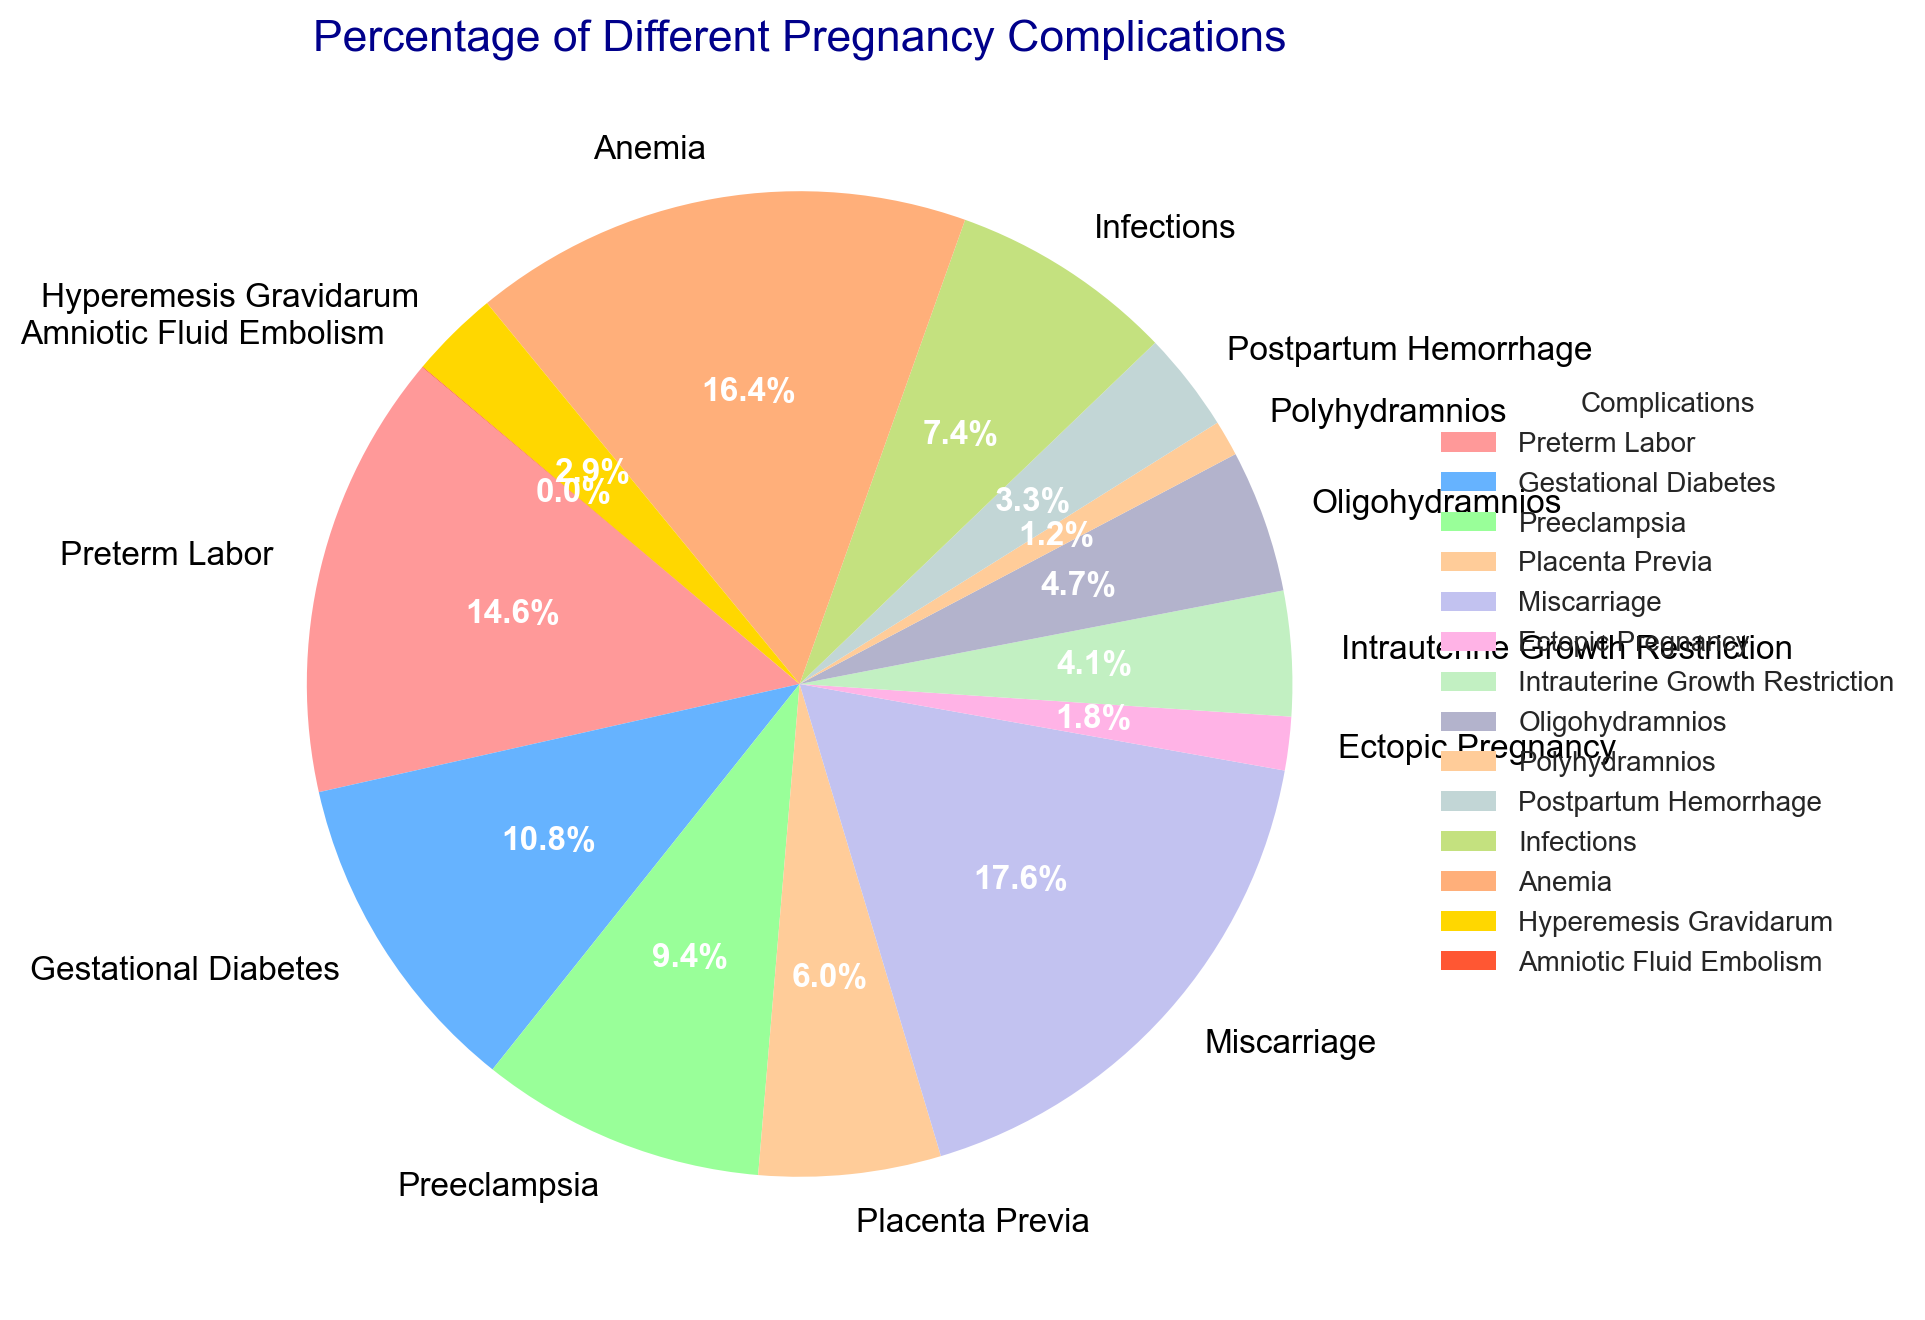Which complication has the highest percentage? By observing the sizes of the slices in the pie chart, you can determine that the largest slice represents the complication with the highest percentage.
Answer: Miscarriage Which two complications have the smallest percentages? Identify the two smallest slices in the pie chart, which represent the complications with the smallest percentages.
Answer: Amniotic Fluid Embolism, Polyhydramnios How much more common is anemia compared to preeclampsia? Locate the slices for anemia (14.0%) and preeclampsia (8.0%) and subtract the percentage of preeclampsia from the percentage of anemia.
Answer: 6% What is the total percentage of preterm labor and gestational diabetes combined? Add the percentages of preterm labor (12.5%) and gestational diabetes (9.2%).
Answer: 21.7% Which complication is represented by a color that is shades of yellows? Find the slice shaded in yellows and identify the complication it represents from the label.
Answer: Polyhydramnios Is infections more or less common than oligohydramnios? Compare the slice representing infections (6.3%) with the slice representing oligohydramnios (4.0%).
Answer: More common Which two complications combined nearly equal the percentage of miscarriage? Identify the complications whose combined percentage is close to the percentage of miscarriage (15.0%). Summing anemia (14.0%) with any other complication does not help, but Hyperemesis Gravidarum (2.5%), Intrauterine Growth Restriction (3.5%), Postpartum Hemorrhage (2.8%) bring you close.
Answer: Anemia and Hyperemesis Gravidarum What is the cumulative percentage of complications less common than 5%? Add the percentages of ectopic pregnancy (1.5%), intrauterine growth restriction (3.5%), oligohydramnios (4.0%), polyhydramnios (1.0%), postpartum hemorrhage (2.8%), hyperemesis gravidarum (2.5%), and amniotic fluid embolism (0.02%).
Answer: 15.3% How much more common is preterm labor than placenta previa? Subtract the percentage of placenta previa (5.1%) from the percentage of preterm labor (12.5%).
Answer: 7.4% Which complication is represented by the green slice, and what is its percentage? Identify the green slice in the pie chart and read its label.
Answer: Ectopic Pregnancy, 1.5% 